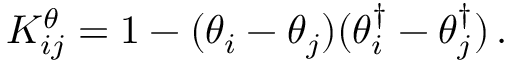Convert formula to latex. <formula><loc_0><loc_0><loc_500><loc_500>K _ { i j } ^ { \theta } = 1 - ( \theta _ { i } - \theta _ { j } ) ( \theta _ { i } ^ { \dagger } - \theta _ { j } ^ { \dagger } ) \, .</formula> 